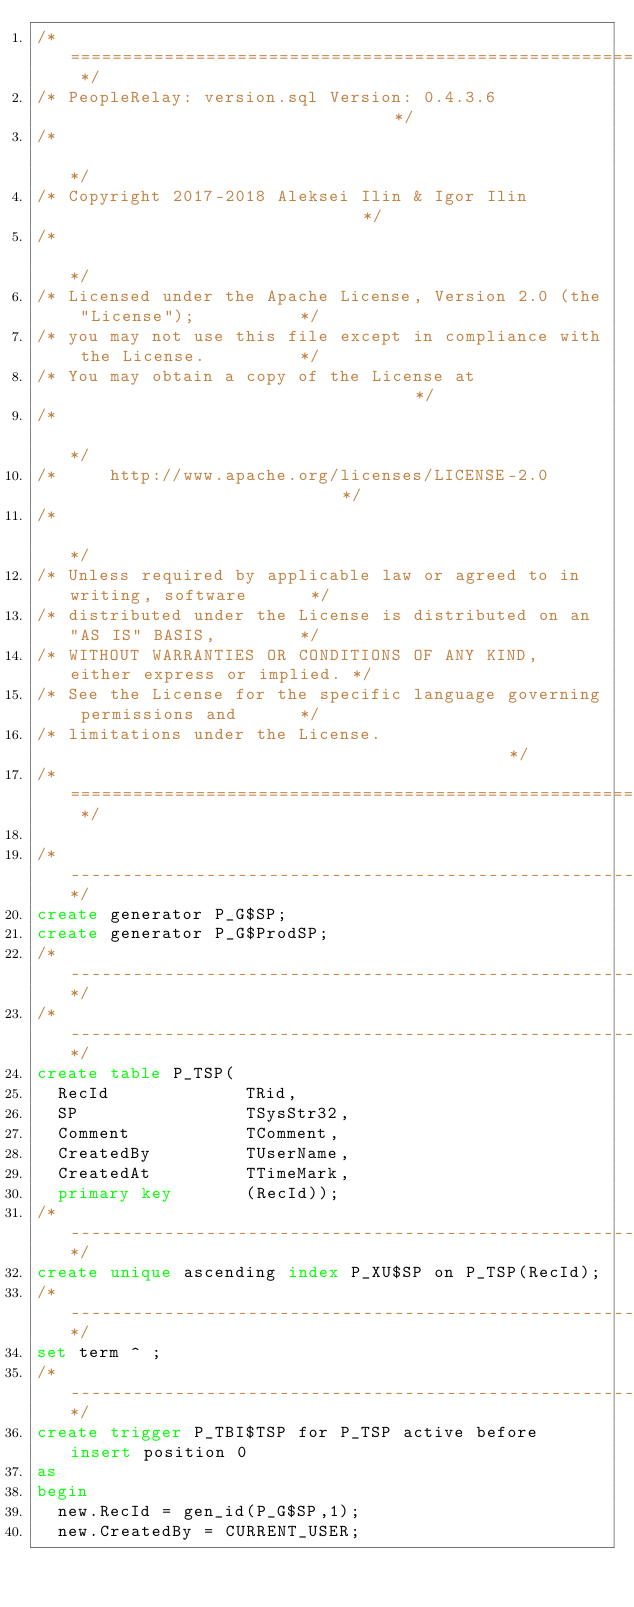Convert code to text. <code><loc_0><loc_0><loc_500><loc_500><_SQL_>/* ======================================================================== */
/* PeopleRelay: version.sql Version: 0.4.3.6                                */
/*                                                                          */
/* Copyright 2017-2018 Aleksei Ilin & Igor Ilin                             */
/*                                                                          */
/* Licensed under the Apache License, Version 2.0 (the "License");          */
/* you may not use this file except in compliance with the License.         */
/* You may obtain a copy of the License at                                  */
/*                                                                          */
/*     http://www.apache.org/licenses/LICENSE-2.0                           */
/*                                                                          */
/* Unless required by applicable law or agreed to in writing, software      */
/* distributed under the License is distributed on an "AS IS" BASIS,        */
/* WITHOUT WARRANTIES OR CONDITIONS OF ANY KIND, either express or implied. */
/* See the License for the specific language governing permissions and      */
/* limitations under the License.                                           */
/* ======================================================================== */

/*-----------------------------------------------------------------------------------------------*/
create generator P_G$SP;
create generator P_G$ProdSP;
/*-----------------------------------------------------------------------------------------------*/
/*-----------------------------------------------------------------------------------------------*/
create table P_TSP(
  RecId             TRid,
  SP                TSysStr32,
  Comment           TComment,
  CreatedBy         TUserName,
  CreatedAt         TTimeMark,
  primary key       (RecId));
/*-----------------------------------------------------------------------------------------------*/
create unique ascending index P_XU$SP on P_TSP(RecId);
/*-----------------------------------------------------------------------------------------------*/
set term ^ ;
/*-----------------------------------------------------------------------------------------------*/
create trigger P_TBI$TSP for P_TSP active before insert position 0
as
begin
  new.RecId = gen_id(P_G$SP,1);
  new.CreatedBy = CURRENT_USER;</code> 